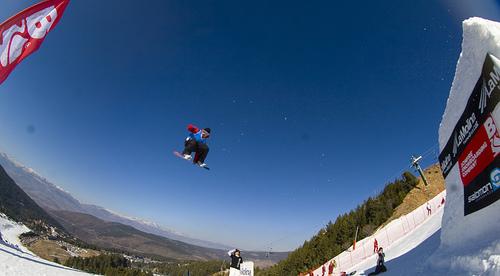What letter is on the red flag?
Quick response, please. B. Are there any mountains around?
Concise answer only. Yes. Why is that person in the air?
Concise answer only. Snowboarding. 